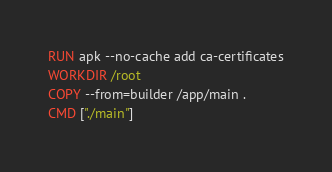Convert code to text. <code><loc_0><loc_0><loc_500><loc_500><_Dockerfile_>RUN apk --no-cache add ca-certificates
WORKDIR /root
COPY --from=builder /app/main .
CMD ["./main"] 
</code> 